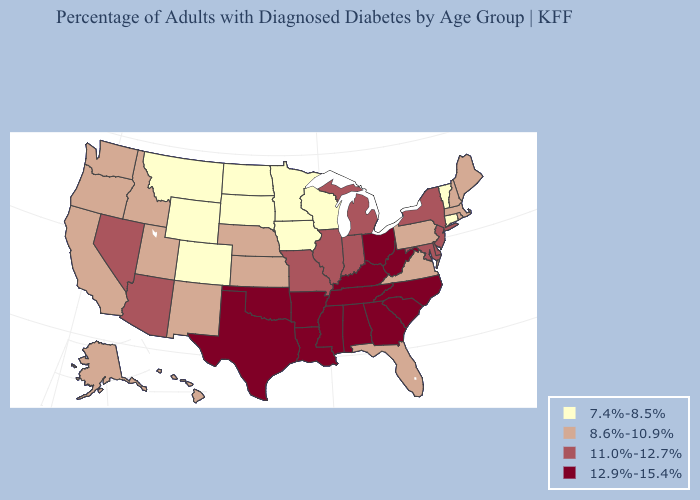Does Nevada have a higher value than Connecticut?
Give a very brief answer. Yes. Does New York have the highest value in the Northeast?
Keep it brief. Yes. Does Alaska have the same value as Oregon?
Give a very brief answer. Yes. Does Nevada have a lower value than Nebraska?
Write a very short answer. No. Does the first symbol in the legend represent the smallest category?
Be succinct. Yes. Among the states that border Georgia , which have the highest value?
Answer briefly. Alabama, North Carolina, South Carolina, Tennessee. What is the value of Kentucky?
Quick response, please. 12.9%-15.4%. Among the states that border South Carolina , which have the lowest value?
Keep it brief. Georgia, North Carolina. Which states hav the highest value in the Northeast?
Short answer required. New Jersey, New York. What is the value of South Dakota?
Short answer required. 7.4%-8.5%. Is the legend a continuous bar?
Give a very brief answer. No. Which states have the lowest value in the Northeast?
Be succinct. Connecticut, Vermont. What is the highest value in the South ?
Quick response, please. 12.9%-15.4%. What is the value of Ohio?
Short answer required. 12.9%-15.4%. What is the highest value in the MidWest ?
Quick response, please. 12.9%-15.4%. 